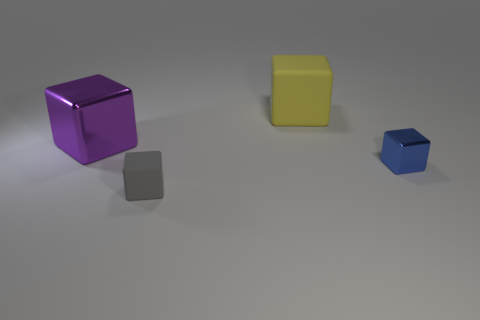Add 2 rubber blocks. How many objects exist? 6 Subtract all cyan blocks. Subtract all purple balls. How many blocks are left? 4 Subtract all large blocks. Subtract all big yellow matte blocks. How many objects are left? 1 Add 2 gray objects. How many gray objects are left? 3 Add 1 blue objects. How many blue objects exist? 2 Subtract 1 gray blocks. How many objects are left? 3 